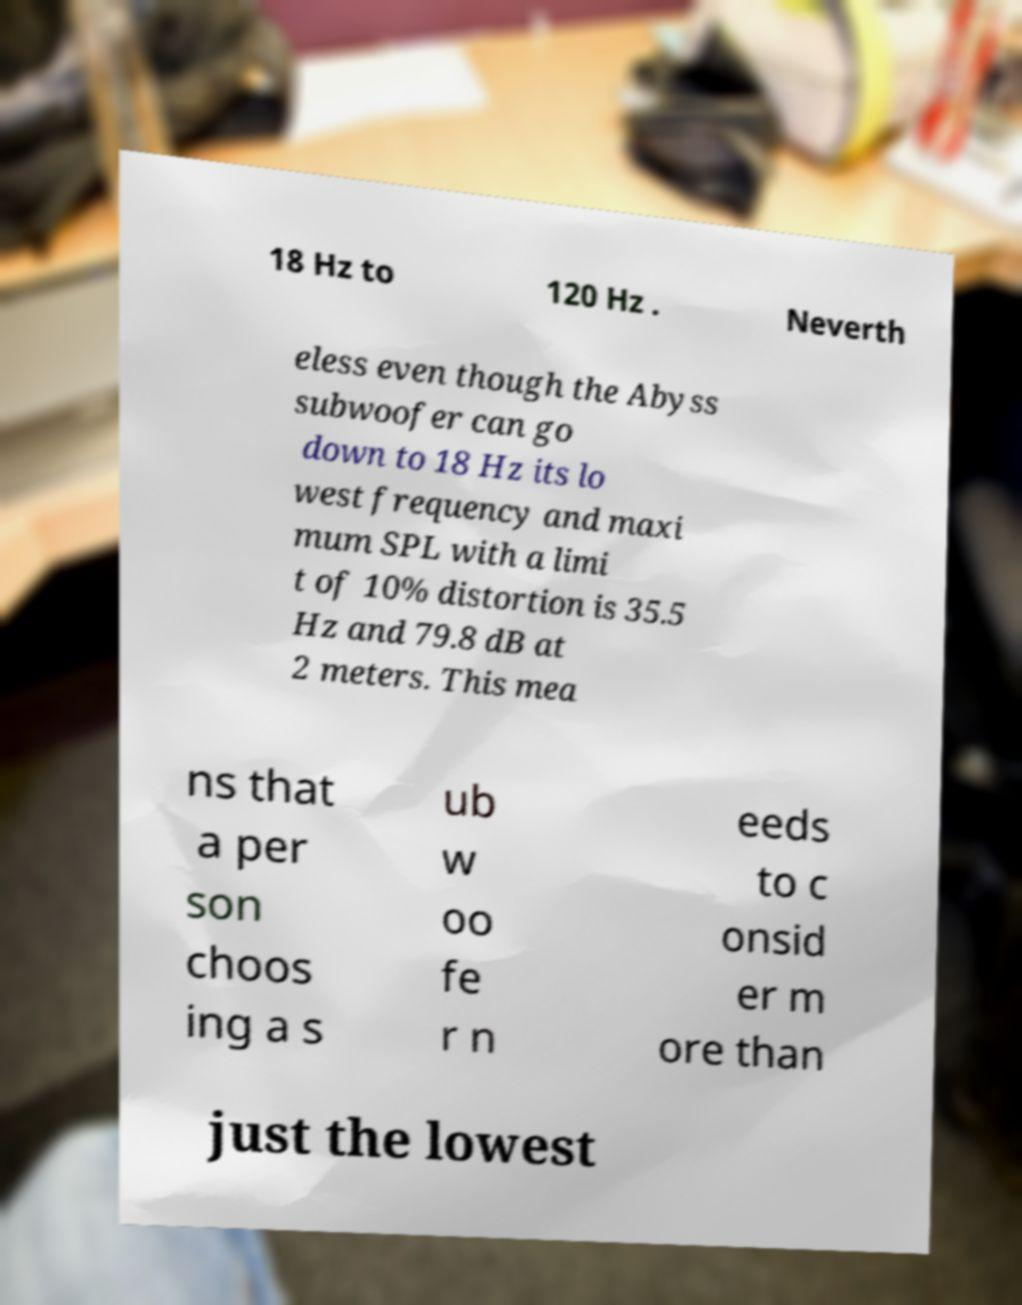Can you read and provide the text displayed in the image?This photo seems to have some interesting text. Can you extract and type it out for me? 18 Hz to 120 Hz . Neverth eless even though the Abyss subwoofer can go down to 18 Hz its lo west frequency and maxi mum SPL with a limi t of 10% distortion is 35.5 Hz and 79.8 dB at 2 meters. This mea ns that a per son choos ing a s ub w oo fe r n eeds to c onsid er m ore than just the lowest 